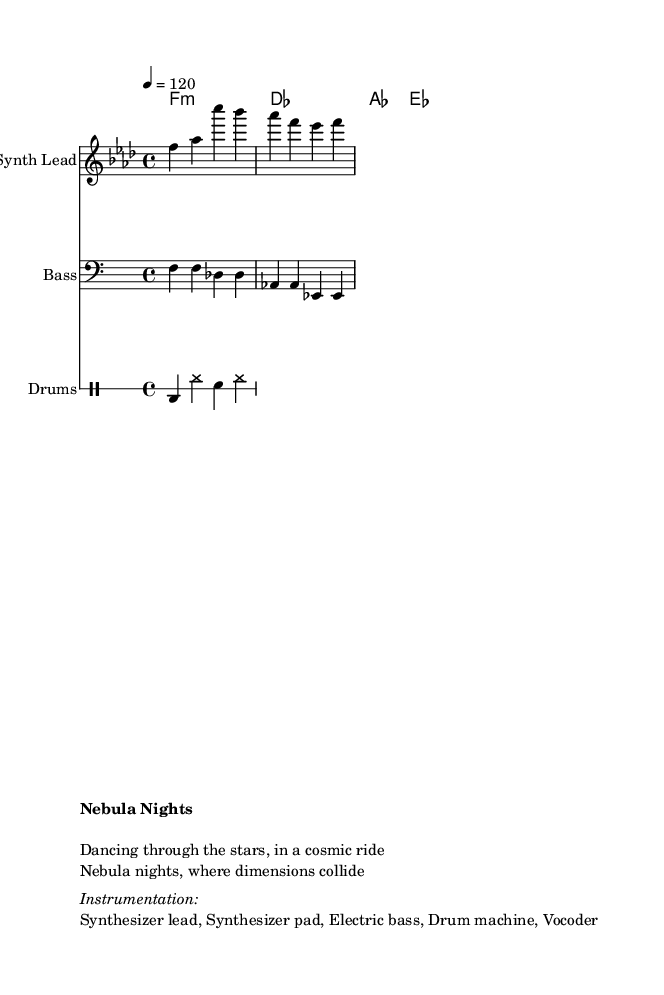What is the key signature of this music? The key signature in the music is indicated by the use of a flat on the B line, signifying F minor, which has four flats (B♭, E♭, A♭, D♭).
Answer: F minor What is the time signature? The time signature is represented as 4/4, which means there are four beats in each measure and the quarter note receives one beat.
Answer: 4/4 What is the tempo marking? The tempo is marked at 120 BPM, indicated by the symbol "4 = 120," specifying that the quarter note should be played at a speed of 120 beats per minute.
Answer: 120 What is the instrumentation listed in the score? The instruments used in the score are specified in the markup section where it mentions "Synthesizer lead, Synthesizer pad, Electric bass, Drum machine, Vocoder."
Answer: Synthesizer lead, Synthesizer pad, Electric bass, Drum machine, Vocoder What mood do the lyrics suggest? The lyrics "Dancing through the stars, in a cosmic ride" and "Nebula nights, where dimensions collide" evoke a feeling of excitement and wonder, fitting a futuristic disco theme.
Answer: Excitement and wonder What type of effect does the bass line utilize? The bass line moves primarily in a repetitive manner, showcasing the funk and groove typically associated with disco music, which is effective for dance tracks.
Answer: Repetitive groove What thematic element do the lyrics incorporate? The lyrics feature a sci-fi theme through references to "nebula" and "dimensions," blending cosmic imagery with dance vibes typical of disco music.
Answer: Sci-fi theme 